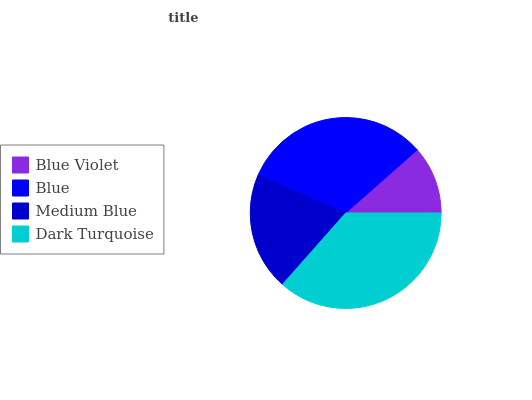Is Blue Violet the minimum?
Answer yes or no. Yes. Is Dark Turquoise the maximum?
Answer yes or no. Yes. Is Blue the minimum?
Answer yes or no. No. Is Blue the maximum?
Answer yes or no. No. Is Blue greater than Blue Violet?
Answer yes or no. Yes. Is Blue Violet less than Blue?
Answer yes or no. Yes. Is Blue Violet greater than Blue?
Answer yes or no. No. Is Blue less than Blue Violet?
Answer yes or no. No. Is Blue the high median?
Answer yes or no. Yes. Is Medium Blue the low median?
Answer yes or no. Yes. Is Blue Violet the high median?
Answer yes or no. No. Is Dark Turquoise the low median?
Answer yes or no. No. 